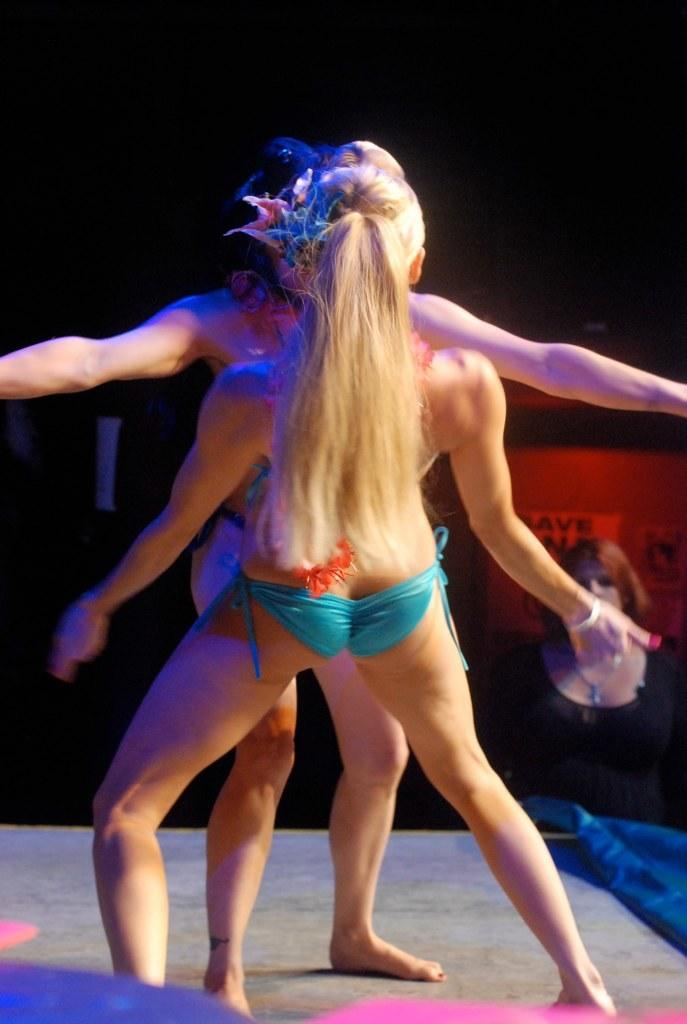What are the two women in the image doing? The two women are dancing in the image. Where is the dancing taking place? The dancing is taking place on the floor. Can you describe the presence of another person in the image? There is a person watching in the background. What time of day was the image taken? The image was taken during night time. How many sheep can be seen in the image? There are no sheep present in the image. What type of power source is being used by the women while dancing? The image does not provide information about any power source being used by the women while dancing. 